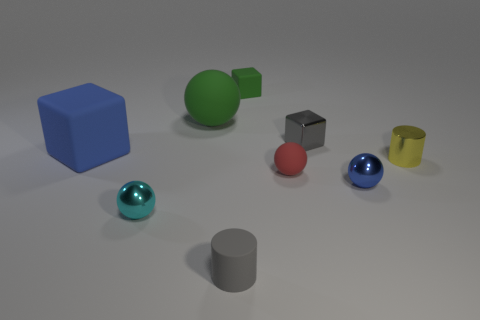There is a rubber cylinder that is the same size as the green block; what is its color?
Offer a terse response. Gray. There is a thing that is in front of the tiny shiny cylinder and left of the large green ball; what shape is it?
Make the answer very short. Sphere. How big is the blue thing in front of the blue cube that is behind the yellow metallic cylinder?
Ensure brevity in your answer.  Small. What number of cubes have the same color as the matte cylinder?
Your answer should be very brief. 1. What number of other things are the same size as the yellow cylinder?
Offer a terse response. 6. What size is the rubber object that is right of the tiny gray matte cylinder and on the left side of the tiny red thing?
Keep it short and to the point. Small. What number of tiny gray metallic things are the same shape as the big blue object?
Your response must be concise. 1. What is the material of the tiny yellow cylinder?
Your answer should be compact. Metal. Is the large green thing the same shape as the tiny gray metallic thing?
Ensure brevity in your answer.  No. Is there a small gray cylinder made of the same material as the large blue block?
Your answer should be very brief. Yes. 